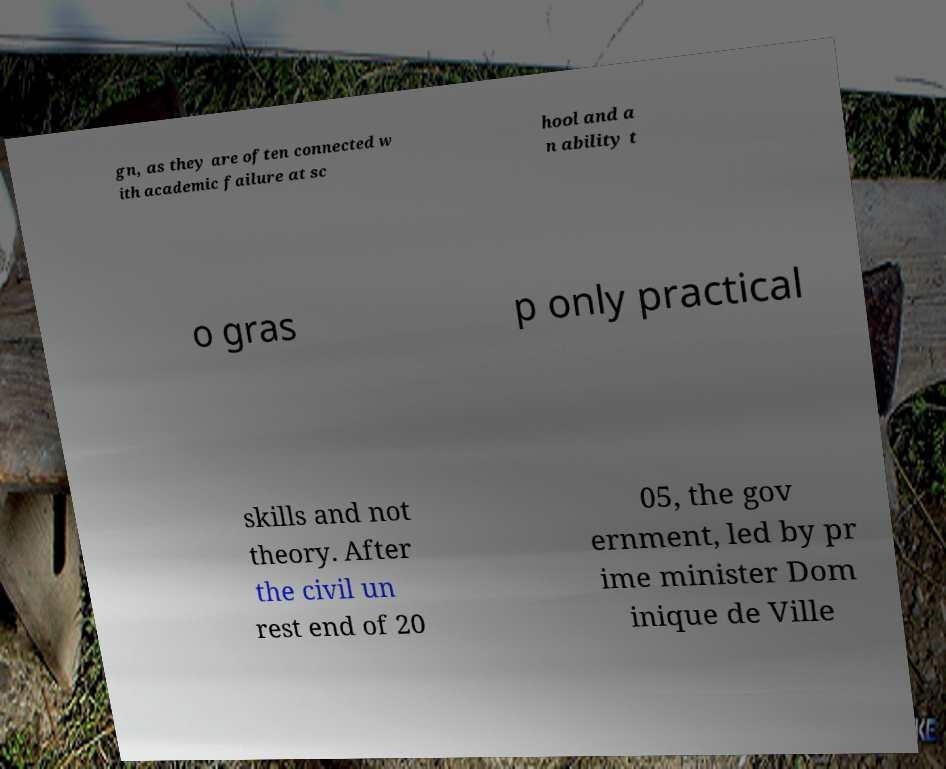For documentation purposes, I need the text within this image transcribed. Could you provide that? gn, as they are often connected w ith academic failure at sc hool and a n ability t o gras p only practical skills and not theory. After the civil un rest end of 20 05, the gov ernment, led by pr ime minister Dom inique de Ville 